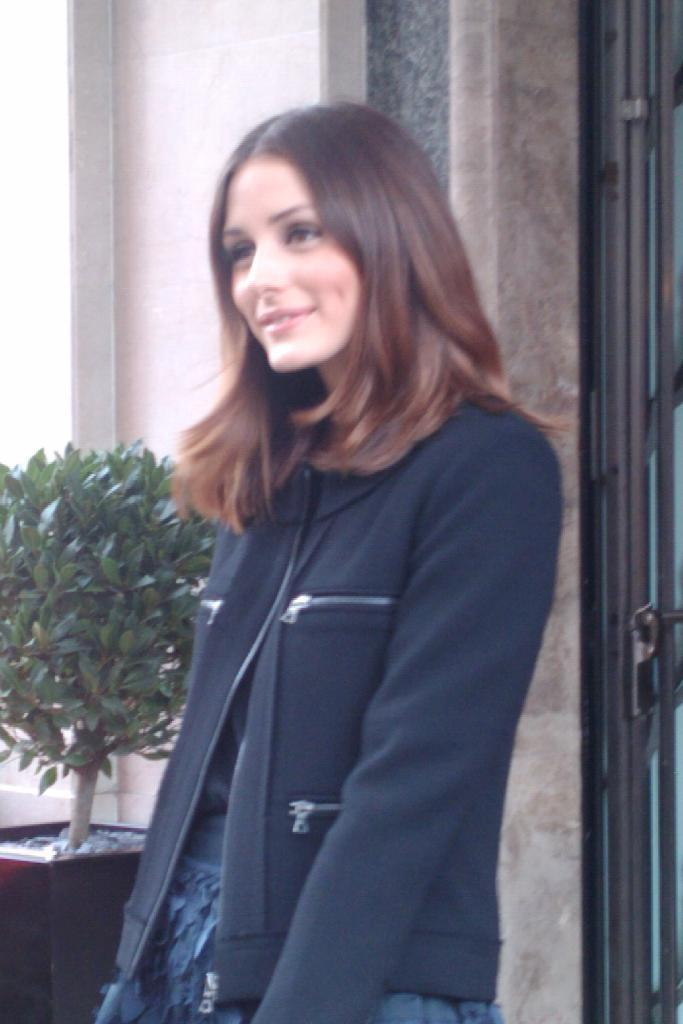Who is the main subject in the image? There is a woman in the center of the image. What can be seen in the background of the image? There is a house plant and a wall in the background of the image. What type of grain is being harvested in the image? There is no grain or harvesting activity present in the image. How many wings can be seen on the woman in the image? The woman in the image does not have any wings. 